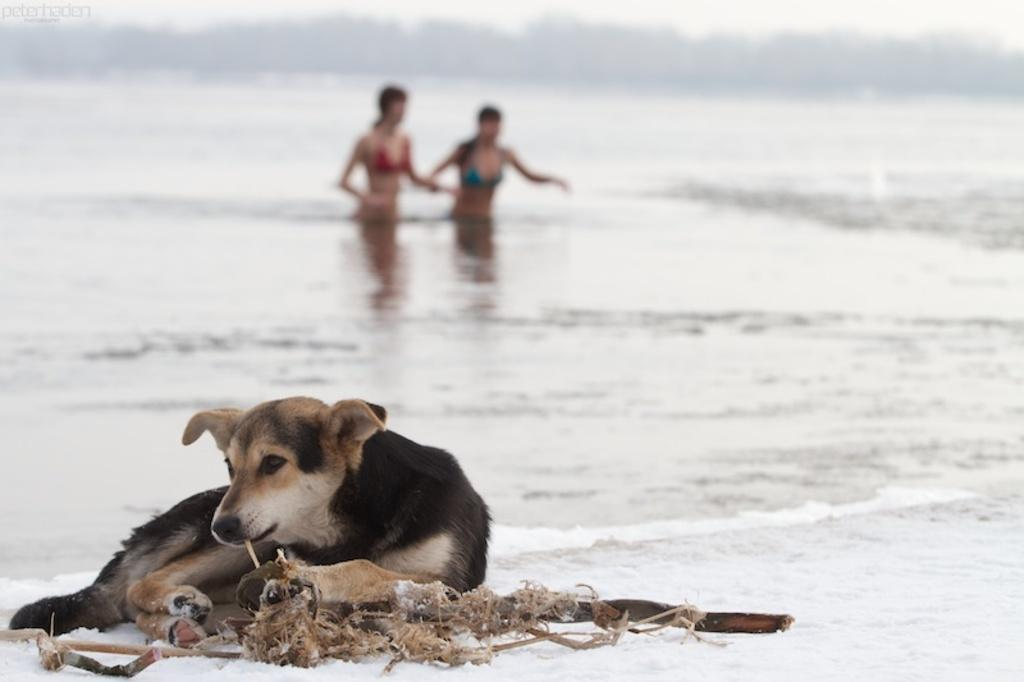What animal can be seen in the image? There is a dog in the image. Where is the dog located? The dog is sitting on the beach side. What can be seen in the background of the image? There are two women in the background of the image. What are the women doing in the image? The women are coming out of the water. What is the reason for the shocking scene in the image? There is no shocking scene present in the image; it features a dog sitting on the beach and two women coming out of the water. 